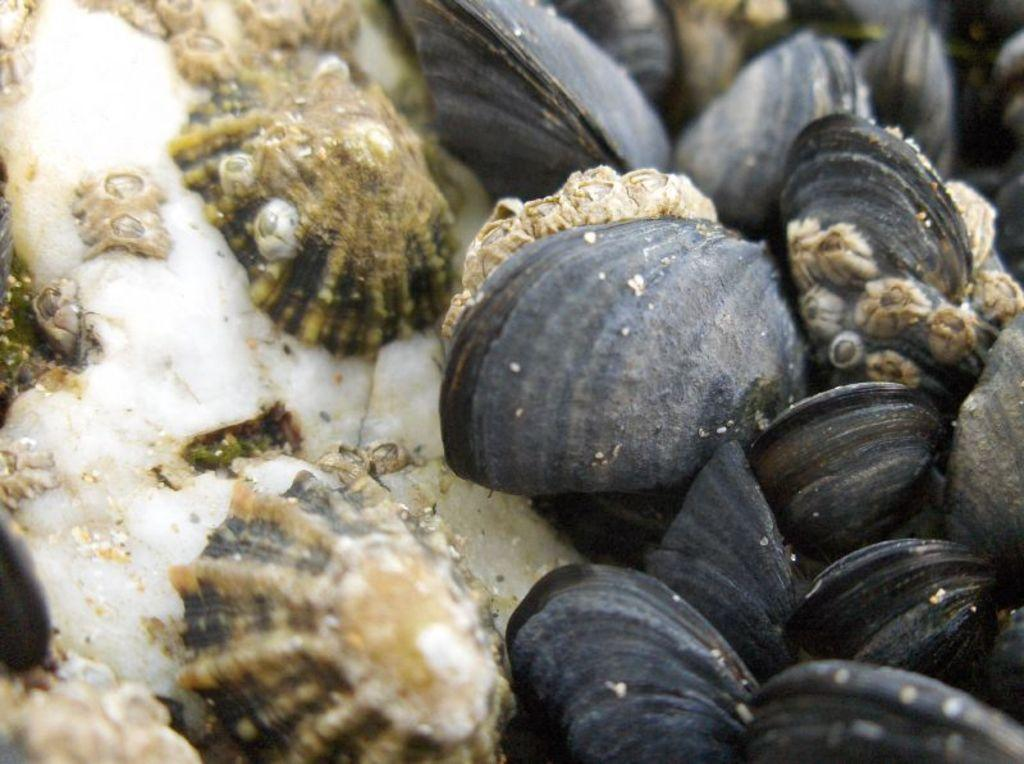What is located in the center of the image? There are shells in the center of the image. How many hands are visible in the image? There are no hands visible in the image; it only features shells in the center. What is the cause of the shells stretching in the image? The shells are not stretching in the image, and there is no cause for stretching mentioned or implied. 